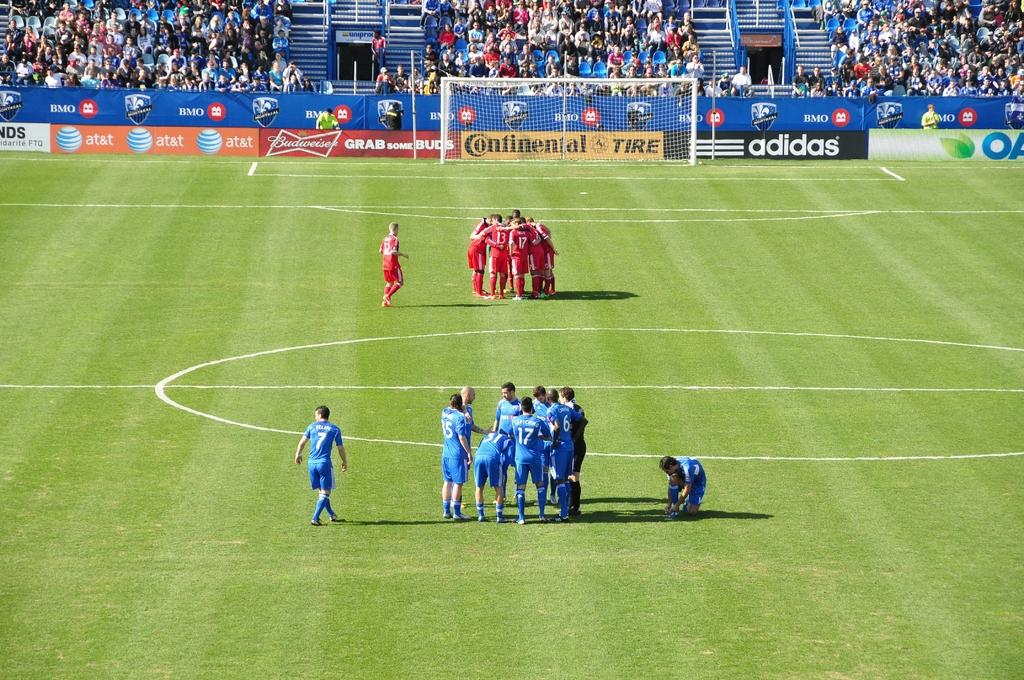What is the main activity taking place in the image? There is a group of people on the ground, which suggests they might be playing a sport or participating in an activity. What structure is present in the image? There is a goal post in the image, which is commonly associated with sports like soccer or football. What type of barrier is visible in the image? There is a fence in the image, which could be used to separate the playing area from the audience or to keep the ball in bounds. What can be seen on the banners in the image? There are banners with text in the image, which might indicate a team name, event, or sponsor. What type of support structures are present in the image? There are metal poles in the image, which could be used to hold up the banners, goal post, or other equipment. Who is watching the activity in the image? There is a group of audience in the image, which suggests that the activity is being observed or enjoyed by others. How does the chicken contribute to the science experiment in the image? There is no chicken or science experiment present in the image; it features a group of people, a goal post, a fence, banners, metal poles, and a group of audience. 